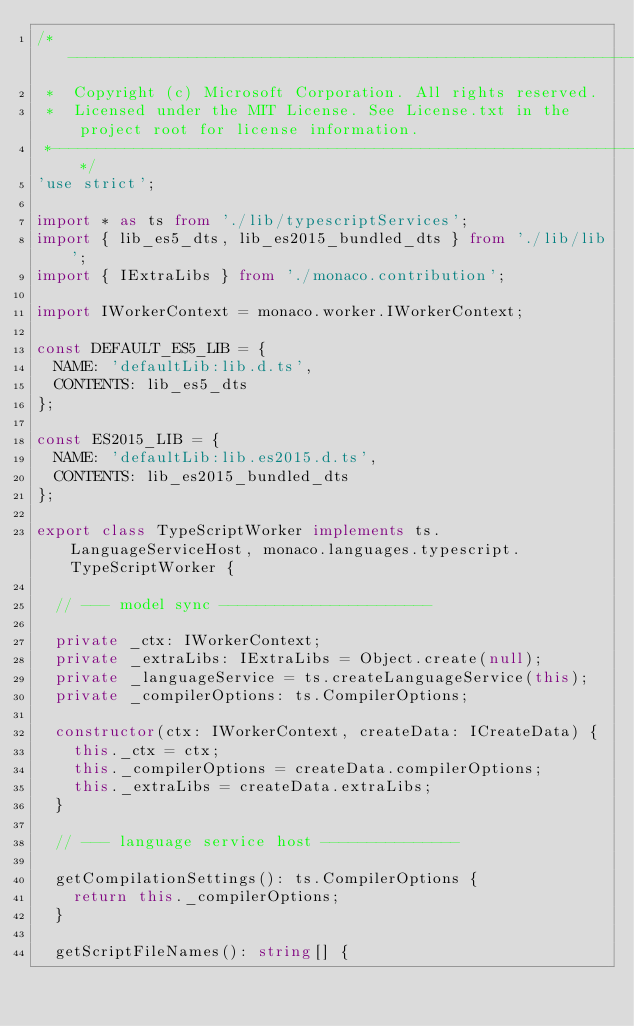Convert code to text. <code><loc_0><loc_0><loc_500><loc_500><_TypeScript_>/*---------------------------------------------------------------------------------------------
 *  Copyright (c) Microsoft Corporation. All rights reserved.
 *  Licensed under the MIT License. See License.txt in the project root for license information.
 *--------------------------------------------------------------------------------------------*/
'use strict';

import * as ts from './lib/typescriptServices';
import { lib_es5_dts, lib_es2015_bundled_dts } from './lib/lib';
import { IExtraLibs } from './monaco.contribution';

import IWorkerContext = monaco.worker.IWorkerContext;

const DEFAULT_ES5_LIB = {
	NAME: 'defaultLib:lib.d.ts',
	CONTENTS: lib_es5_dts
};

const ES2015_LIB = {
	NAME: 'defaultLib:lib.es2015.d.ts',
	CONTENTS: lib_es2015_bundled_dts
};

export class TypeScriptWorker implements ts.LanguageServiceHost, monaco.languages.typescript.TypeScriptWorker {

	// --- model sync -----------------------

	private _ctx: IWorkerContext;
	private _extraLibs: IExtraLibs = Object.create(null);
	private _languageService = ts.createLanguageService(this);
	private _compilerOptions: ts.CompilerOptions;

	constructor(ctx: IWorkerContext, createData: ICreateData) {
		this._ctx = ctx;
		this._compilerOptions = createData.compilerOptions;
		this._extraLibs = createData.extraLibs;
	}

	// --- language service host ---------------

	getCompilationSettings(): ts.CompilerOptions {
		return this._compilerOptions;
	}

	getScriptFileNames(): string[] {</code> 